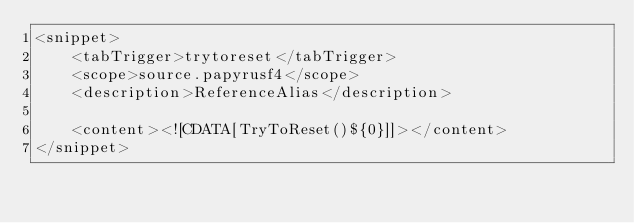<code> <loc_0><loc_0><loc_500><loc_500><_XML_><snippet>
    <tabTrigger>trytoreset</tabTrigger>
    <scope>source.papyrusf4</scope>
    <description>ReferenceAlias</description>

    <content><![CDATA[TryToReset()${0}]]></content>
</snippet>
</code> 